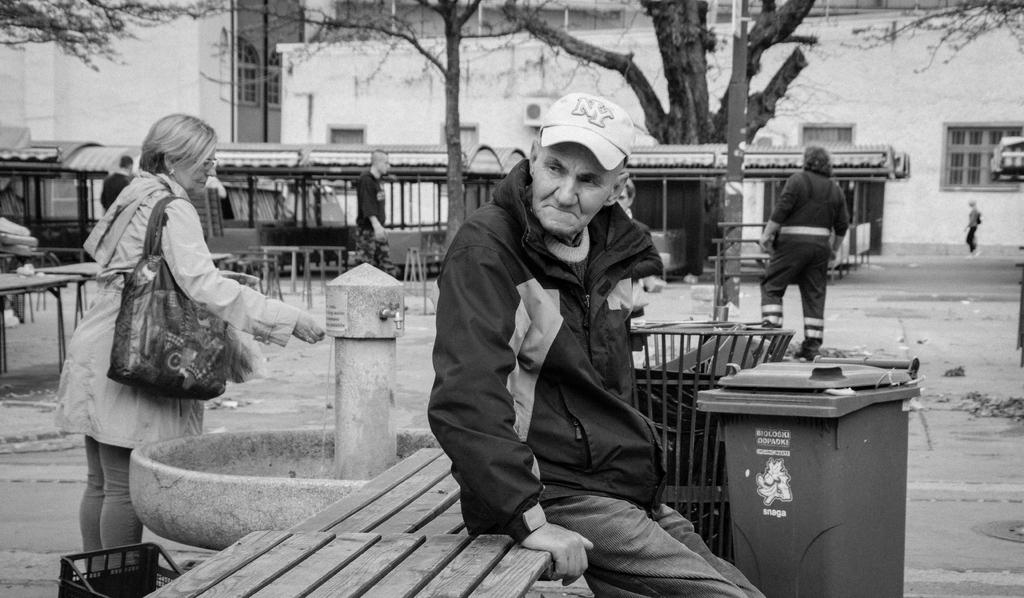Provide a one-sentence caption for the provided image. a man with a hat on that says NY on it. 